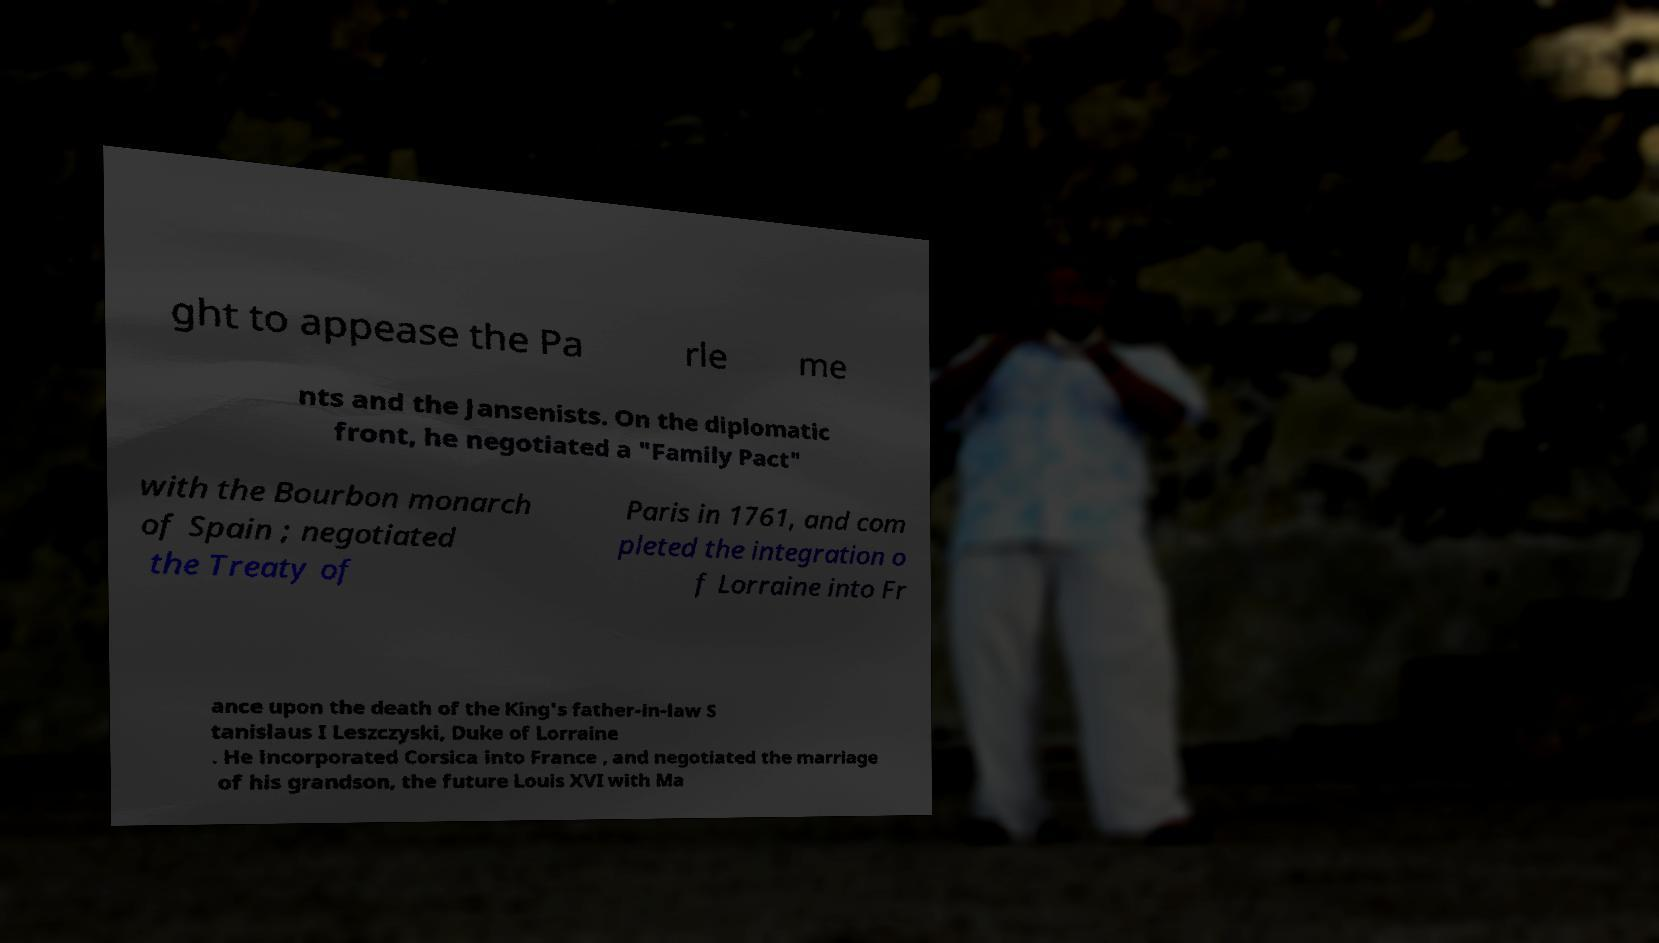For documentation purposes, I need the text within this image transcribed. Could you provide that? ght to appease the Pa rle me nts and the Jansenists. On the diplomatic front, he negotiated a "Family Pact" with the Bourbon monarch of Spain ; negotiated the Treaty of Paris in 1761, and com pleted the integration o f Lorraine into Fr ance upon the death of the King's father-in-law S tanislaus I Leszczyski, Duke of Lorraine . He incorporated Corsica into France , and negotiated the marriage of his grandson, the future Louis XVI with Ma 